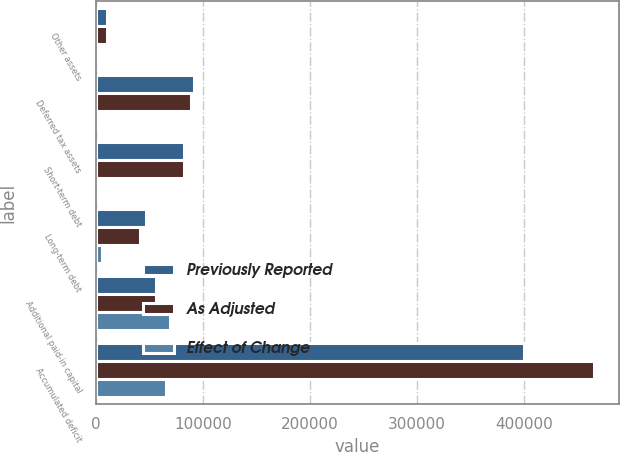Convert chart to OTSL. <chart><loc_0><loc_0><loc_500><loc_500><stacked_bar_chart><ecel><fcel>Other assets<fcel>Deferred tax assets<fcel>Short-term debt<fcel>Long-term debt<fcel>Additional paid-in capital<fcel>Accumulated deficit<nl><fcel>Previously Reported<fcel>10283<fcel>91479<fcel>82617<fcel>47116<fcel>56238<fcel>399794<nl><fcel>As Adjusted<fcel>9864<fcel>89163<fcel>81865<fcel>41483<fcel>56238<fcel>465154<nl><fcel>Effect of Change<fcel>419<fcel>2316<fcel>752<fcel>5633<fcel>69010<fcel>65360<nl></chart> 